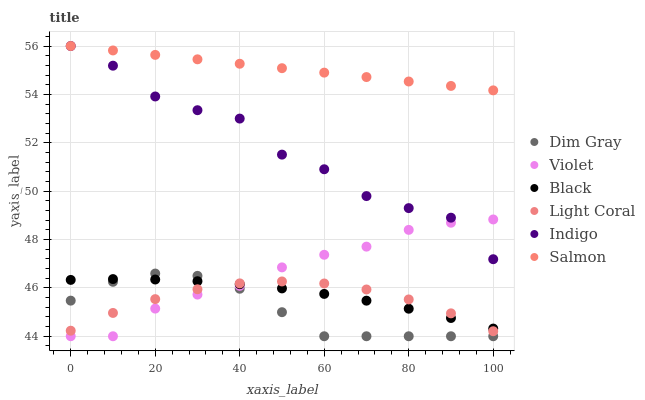Does Dim Gray have the minimum area under the curve?
Answer yes or no. Yes. Does Salmon have the maximum area under the curve?
Answer yes or no. Yes. Does Indigo have the minimum area under the curve?
Answer yes or no. No. Does Indigo have the maximum area under the curve?
Answer yes or no. No. Is Salmon the smoothest?
Answer yes or no. Yes. Is Indigo the roughest?
Answer yes or no. Yes. Is Indigo the smoothest?
Answer yes or no. No. Is Salmon the roughest?
Answer yes or no. No. Does Dim Gray have the lowest value?
Answer yes or no. Yes. Does Indigo have the lowest value?
Answer yes or no. No. Does Salmon have the highest value?
Answer yes or no. Yes. Does Light Coral have the highest value?
Answer yes or no. No. Is Black less than Indigo?
Answer yes or no. Yes. Is Salmon greater than Dim Gray?
Answer yes or no. Yes. Does Light Coral intersect Black?
Answer yes or no. Yes. Is Light Coral less than Black?
Answer yes or no. No. Is Light Coral greater than Black?
Answer yes or no. No. Does Black intersect Indigo?
Answer yes or no. No. 